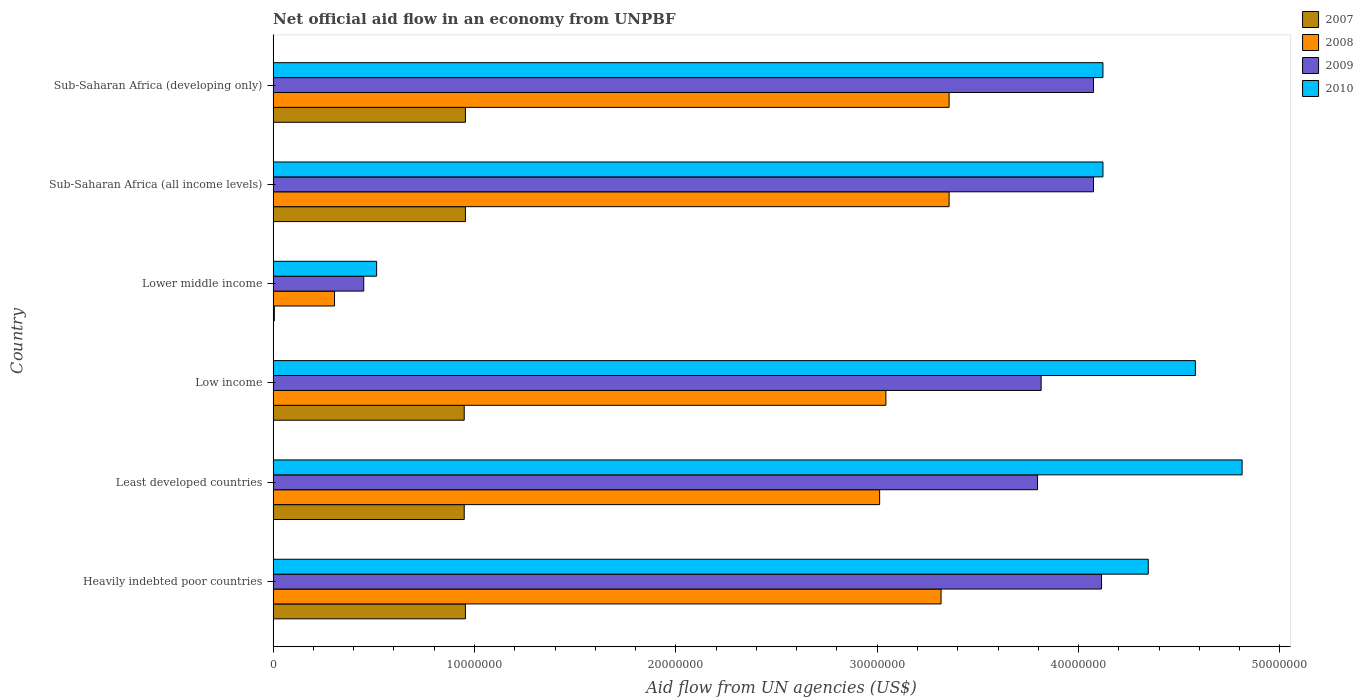How many groups of bars are there?
Offer a terse response. 6. How many bars are there on the 5th tick from the top?
Make the answer very short. 4. How many bars are there on the 4th tick from the bottom?
Your response must be concise. 4. What is the label of the 6th group of bars from the top?
Your response must be concise. Heavily indebted poor countries. In how many cases, is the number of bars for a given country not equal to the number of legend labels?
Provide a short and direct response. 0. What is the net official aid flow in 2009 in Sub-Saharan Africa (developing only)?
Keep it short and to the point. 4.07e+07. Across all countries, what is the maximum net official aid flow in 2010?
Your answer should be compact. 4.81e+07. Across all countries, what is the minimum net official aid flow in 2008?
Your response must be concise. 3.05e+06. In which country was the net official aid flow in 2010 maximum?
Ensure brevity in your answer.  Least developed countries. In which country was the net official aid flow in 2009 minimum?
Keep it short and to the point. Lower middle income. What is the total net official aid flow in 2008 in the graph?
Give a very brief answer. 1.64e+08. What is the difference between the net official aid flow in 2010 in Low income and that in Sub-Saharan Africa (all income levels)?
Offer a terse response. 4.59e+06. What is the difference between the net official aid flow in 2008 in Heavily indebted poor countries and the net official aid flow in 2009 in Low income?
Ensure brevity in your answer.  -4.97e+06. What is the average net official aid flow in 2008 per country?
Provide a succinct answer. 2.73e+07. What is the difference between the net official aid flow in 2008 and net official aid flow in 2009 in Low income?
Give a very brief answer. -7.71e+06. What is the ratio of the net official aid flow in 2010 in Low income to that in Sub-Saharan Africa (developing only)?
Your response must be concise. 1.11. Is the net official aid flow in 2010 in Heavily indebted poor countries less than that in Sub-Saharan Africa (developing only)?
Your answer should be compact. No. Is the difference between the net official aid flow in 2008 in Low income and Sub-Saharan Africa (developing only) greater than the difference between the net official aid flow in 2009 in Low income and Sub-Saharan Africa (developing only)?
Ensure brevity in your answer.  No. What is the difference between the highest and the lowest net official aid flow in 2009?
Your answer should be very brief. 3.66e+07. Is the sum of the net official aid flow in 2009 in Least developed countries and Low income greater than the maximum net official aid flow in 2008 across all countries?
Ensure brevity in your answer.  Yes. What does the 3rd bar from the top in Heavily indebted poor countries represents?
Offer a terse response. 2008. Are all the bars in the graph horizontal?
Your answer should be compact. Yes. How many countries are there in the graph?
Ensure brevity in your answer.  6. What is the difference between two consecutive major ticks on the X-axis?
Give a very brief answer. 1.00e+07. Does the graph contain grids?
Provide a succinct answer. No. What is the title of the graph?
Your answer should be very brief. Net official aid flow in an economy from UNPBF. Does "1964" appear as one of the legend labels in the graph?
Make the answer very short. No. What is the label or title of the X-axis?
Provide a short and direct response. Aid flow from UN agencies (US$). What is the Aid flow from UN agencies (US$) of 2007 in Heavily indebted poor countries?
Your response must be concise. 9.55e+06. What is the Aid flow from UN agencies (US$) of 2008 in Heavily indebted poor countries?
Make the answer very short. 3.32e+07. What is the Aid flow from UN agencies (US$) in 2009 in Heavily indebted poor countries?
Provide a succinct answer. 4.11e+07. What is the Aid flow from UN agencies (US$) of 2010 in Heavily indebted poor countries?
Your answer should be compact. 4.35e+07. What is the Aid flow from UN agencies (US$) in 2007 in Least developed countries?
Give a very brief answer. 9.49e+06. What is the Aid flow from UN agencies (US$) of 2008 in Least developed countries?
Offer a very short reply. 3.01e+07. What is the Aid flow from UN agencies (US$) in 2009 in Least developed countries?
Offer a very short reply. 3.80e+07. What is the Aid flow from UN agencies (US$) of 2010 in Least developed countries?
Keep it short and to the point. 4.81e+07. What is the Aid flow from UN agencies (US$) of 2007 in Low income?
Offer a terse response. 9.49e+06. What is the Aid flow from UN agencies (US$) of 2008 in Low income?
Keep it short and to the point. 3.04e+07. What is the Aid flow from UN agencies (US$) of 2009 in Low income?
Ensure brevity in your answer.  3.81e+07. What is the Aid flow from UN agencies (US$) of 2010 in Low income?
Your response must be concise. 4.58e+07. What is the Aid flow from UN agencies (US$) of 2007 in Lower middle income?
Your answer should be compact. 6.00e+04. What is the Aid flow from UN agencies (US$) of 2008 in Lower middle income?
Ensure brevity in your answer.  3.05e+06. What is the Aid flow from UN agencies (US$) of 2009 in Lower middle income?
Provide a short and direct response. 4.50e+06. What is the Aid flow from UN agencies (US$) in 2010 in Lower middle income?
Keep it short and to the point. 5.14e+06. What is the Aid flow from UN agencies (US$) of 2007 in Sub-Saharan Africa (all income levels)?
Ensure brevity in your answer.  9.55e+06. What is the Aid flow from UN agencies (US$) of 2008 in Sub-Saharan Africa (all income levels)?
Your response must be concise. 3.36e+07. What is the Aid flow from UN agencies (US$) of 2009 in Sub-Saharan Africa (all income levels)?
Your response must be concise. 4.07e+07. What is the Aid flow from UN agencies (US$) of 2010 in Sub-Saharan Africa (all income levels)?
Your response must be concise. 4.12e+07. What is the Aid flow from UN agencies (US$) in 2007 in Sub-Saharan Africa (developing only)?
Keep it short and to the point. 9.55e+06. What is the Aid flow from UN agencies (US$) of 2008 in Sub-Saharan Africa (developing only)?
Provide a short and direct response. 3.36e+07. What is the Aid flow from UN agencies (US$) of 2009 in Sub-Saharan Africa (developing only)?
Offer a terse response. 4.07e+07. What is the Aid flow from UN agencies (US$) in 2010 in Sub-Saharan Africa (developing only)?
Provide a short and direct response. 4.12e+07. Across all countries, what is the maximum Aid flow from UN agencies (US$) of 2007?
Offer a very short reply. 9.55e+06. Across all countries, what is the maximum Aid flow from UN agencies (US$) in 2008?
Your answer should be very brief. 3.36e+07. Across all countries, what is the maximum Aid flow from UN agencies (US$) of 2009?
Your answer should be compact. 4.11e+07. Across all countries, what is the maximum Aid flow from UN agencies (US$) in 2010?
Offer a terse response. 4.81e+07. Across all countries, what is the minimum Aid flow from UN agencies (US$) of 2007?
Offer a very short reply. 6.00e+04. Across all countries, what is the minimum Aid flow from UN agencies (US$) in 2008?
Provide a succinct answer. 3.05e+06. Across all countries, what is the minimum Aid flow from UN agencies (US$) of 2009?
Ensure brevity in your answer.  4.50e+06. Across all countries, what is the minimum Aid flow from UN agencies (US$) of 2010?
Ensure brevity in your answer.  5.14e+06. What is the total Aid flow from UN agencies (US$) in 2007 in the graph?
Ensure brevity in your answer.  4.77e+07. What is the total Aid flow from UN agencies (US$) in 2008 in the graph?
Provide a succinct answer. 1.64e+08. What is the total Aid flow from UN agencies (US$) of 2009 in the graph?
Provide a succinct answer. 2.03e+08. What is the total Aid flow from UN agencies (US$) of 2010 in the graph?
Your answer should be very brief. 2.25e+08. What is the difference between the Aid flow from UN agencies (US$) in 2007 in Heavily indebted poor countries and that in Least developed countries?
Ensure brevity in your answer.  6.00e+04. What is the difference between the Aid flow from UN agencies (US$) of 2008 in Heavily indebted poor countries and that in Least developed countries?
Make the answer very short. 3.05e+06. What is the difference between the Aid flow from UN agencies (US$) of 2009 in Heavily indebted poor countries and that in Least developed countries?
Give a very brief answer. 3.18e+06. What is the difference between the Aid flow from UN agencies (US$) in 2010 in Heavily indebted poor countries and that in Least developed countries?
Your answer should be very brief. -4.66e+06. What is the difference between the Aid flow from UN agencies (US$) in 2008 in Heavily indebted poor countries and that in Low income?
Make the answer very short. 2.74e+06. What is the difference between the Aid flow from UN agencies (US$) of 2009 in Heavily indebted poor countries and that in Low income?
Give a very brief answer. 3.00e+06. What is the difference between the Aid flow from UN agencies (US$) in 2010 in Heavily indebted poor countries and that in Low income?
Provide a succinct answer. -2.34e+06. What is the difference between the Aid flow from UN agencies (US$) in 2007 in Heavily indebted poor countries and that in Lower middle income?
Keep it short and to the point. 9.49e+06. What is the difference between the Aid flow from UN agencies (US$) in 2008 in Heavily indebted poor countries and that in Lower middle income?
Offer a very short reply. 3.01e+07. What is the difference between the Aid flow from UN agencies (US$) of 2009 in Heavily indebted poor countries and that in Lower middle income?
Your answer should be very brief. 3.66e+07. What is the difference between the Aid flow from UN agencies (US$) of 2010 in Heavily indebted poor countries and that in Lower middle income?
Offer a terse response. 3.83e+07. What is the difference between the Aid flow from UN agencies (US$) in 2007 in Heavily indebted poor countries and that in Sub-Saharan Africa (all income levels)?
Offer a terse response. 0. What is the difference between the Aid flow from UN agencies (US$) of 2008 in Heavily indebted poor countries and that in Sub-Saharan Africa (all income levels)?
Provide a short and direct response. -4.00e+05. What is the difference between the Aid flow from UN agencies (US$) of 2009 in Heavily indebted poor countries and that in Sub-Saharan Africa (all income levels)?
Your answer should be compact. 4.00e+05. What is the difference between the Aid flow from UN agencies (US$) of 2010 in Heavily indebted poor countries and that in Sub-Saharan Africa (all income levels)?
Make the answer very short. 2.25e+06. What is the difference between the Aid flow from UN agencies (US$) of 2008 in Heavily indebted poor countries and that in Sub-Saharan Africa (developing only)?
Provide a succinct answer. -4.00e+05. What is the difference between the Aid flow from UN agencies (US$) in 2010 in Heavily indebted poor countries and that in Sub-Saharan Africa (developing only)?
Give a very brief answer. 2.25e+06. What is the difference between the Aid flow from UN agencies (US$) in 2008 in Least developed countries and that in Low income?
Offer a terse response. -3.10e+05. What is the difference between the Aid flow from UN agencies (US$) of 2009 in Least developed countries and that in Low income?
Offer a very short reply. -1.80e+05. What is the difference between the Aid flow from UN agencies (US$) of 2010 in Least developed countries and that in Low income?
Provide a succinct answer. 2.32e+06. What is the difference between the Aid flow from UN agencies (US$) in 2007 in Least developed countries and that in Lower middle income?
Offer a very short reply. 9.43e+06. What is the difference between the Aid flow from UN agencies (US$) of 2008 in Least developed countries and that in Lower middle income?
Give a very brief answer. 2.71e+07. What is the difference between the Aid flow from UN agencies (US$) of 2009 in Least developed countries and that in Lower middle income?
Offer a very short reply. 3.35e+07. What is the difference between the Aid flow from UN agencies (US$) of 2010 in Least developed countries and that in Lower middle income?
Provide a succinct answer. 4.30e+07. What is the difference between the Aid flow from UN agencies (US$) of 2008 in Least developed countries and that in Sub-Saharan Africa (all income levels)?
Your answer should be very brief. -3.45e+06. What is the difference between the Aid flow from UN agencies (US$) of 2009 in Least developed countries and that in Sub-Saharan Africa (all income levels)?
Keep it short and to the point. -2.78e+06. What is the difference between the Aid flow from UN agencies (US$) in 2010 in Least developed countries and that in Sub-Saharan Africa (all income levels)?
Keep it short and to the point. 6.91e+06. What is the difference between the Aid flow from UN agencies (US$) of 2008 in Least developed countries and that in Sub-Saharan Africa (developing only)?
Ensure brevity in your answer.  -3.45e+06. What is the difference between the Aid flow from UN agencies (US$) of 2009 in Least developed countries and that in Sub-Saharan Africa (developing only)?
Make the answer very short. -2.78e+06. What is the difference between the Aid flow from UN agencies (US$) in 2010 in Least developed countries and that in Sub-Saharan Africa (developing only)?
Offer a terse response. 6.91e+06. What is the difference between the Aid flow from UN agencies (US$) in 2007 in Low income and that in Lower middle income?
Keep it short and to the point. 9.43e+06. What is the difference between the Aid flow from UN agencies (US$) of 2008 in Low income and that in Lower middle income?
Your response must be concise. 2.74e+07. What is the difference between the Aid flow from UN agencies (US$) of 2009 in Low income and that in Lower middle income?
Provide a short and direct response. 3.36e+07. What is the difference between the Aid flow from UN agencies (US$) in 2010 in Low income and that in Lower middle income?
Your response must be concise. 4.07e+07. What is the difference between the Aid flow from UN agencies (US$) in 2008 in Low income and that in Sub-Saharan Africa (all income levels)?
Keep it short and to the point. -3.14e+06. What is the difference between the Aid flow from UN agencies (US$) of 2009 in Low income and that in Sub-Saharan Africa (all income levels)?
Your answer should be very brief. -2.60e+06. What is the difference between the Aid flow from UN agencies (US$) of 2010 in Low income and that in Sub-Saharan Africa (all income levels)?
Your answer should be compact. 4.59e+06. What is the difference between the Aid flow from UN agencies (US$) in 2007 in Low income and that in Sub-Saharan Africa (developing only)?
Your answer should be very brief. -6.00e+04. What is the difference between the Aid flow from UN agencies (US$) in 2008 in Low income and that in Sub-Saharan Africa (developing only)?
Your answer should be very brief. -3.14e+06. What is the difference between the Aid flow from UN agencies (US$) of 2009 in Low income and that in Sub-Saharan Africa (developing only)?
Provide a short and direct response. -2.60e+06. What is the difference between the Aid flow from UN agencies (US$) of 2010 in Low income and that in Sub-Saharan Africa (developing only)?
Ensure brevity in your answer.  4.59e+06. What is the difference between the Aid flow from UN agencies (US$) in 2007 in Lower middle income and that in Sub-Saharan Africa (all income levels)?
Give a very brief answer. -9.49e+06. What is the difference between the Aid flow from UN agencies (US$) of 2008 in Lower middle income and that in Sub-Saharan Africa (all income levels)?
Your answer should be very brief. -3.05e+07. What is the difference between the Aid flow from UN agencies (US$) of 2009 in Lower middle income and that in Sub-Saharan Africa (all income levels)?
Keep it short and to the point. -3.62e+07. What is the difference between the Aid flow from UN agencies (US$) of 2010 in Lower middle income and that in Sub-Saharan Africa (all income levels)?
Offer a very short reply. -3.61e+07. What is the difference between the Aid flow from UN agencies (US$) of 2007 in Lower middle income and that in Sub-Saharan Africa (developing only)?
Keep it short and to the point. -9.49e+06. What is the difference between the Aid flow from UN agencies (US$) of 2008 in Lower middle income and that in Sub-Saharan Africa (developing only)?
Make the answer very short. -3.05e+07. What is the difference between the Aid flow from UN agencies (US$) of 2009 in Lower middle income and that in Sub-Saharan Africa (developing only)?
Your answer should be compact. -3.62e+07. What is the difference between the Aid flow from UN agencies (US$) of 2010 in Lower middle income and that in Sub-Saharan Africa (developing only)?
Your answer should be compact. -3.61e+07. What is the difference between the Aid flow from UN agencies (US$) in 2007 in Sub-Saharan Africa (all income levels) and that in Sub-Saharan Africa (developing only)?
Offer a terse response. 0. What is the difference between the Aid flow from UN agencies (US$) in 2009 in Sub-Saharan Africa (all income levels) and that in Sub-Saharan Africa (developing only)?
Give a very brief answer. 0. What is the difference between the Aid flow from UN agencies (US$) of 2007 in Heavily indebted poor countries and the Aid flow from UN agencies (US$) of 2008 in Least developed countries?
Provide a short and direct response. -2.06e+07. What is the difference between the Aid flow from UN agencies (US$) in 2007 in Heavily indebted poor countries and the Aid flow from UN agencies (US$) in 2009 in Least developed countries?
Give a very brief answer. -2.84e+07. What is the difference between the Aid flow from UN agencies (US$) in 2007 in Heavily indebted poor countries and the Aid flow from UN agencies (US$) in 2010 in Least developed countries?
Your answer should be compact. -3.86e+07. What is the difference between the Aid flow from UN agencies (US$) in 2008 in Heavily indebted poor countries and the Aid flow from UN agencies (US$) in 2009 in Least developed countries?
Offer a very short reply. -4.79e+06. What is the difference between the Aid flow from UN agencies (US$) of 2008 in Heavily indebted poor countries and the Aid flow from UN agencies (US$) of 2010 in Least developed countries?
Make the answer very short. -1.50e+07. What is the difference between the Aid flow from UN agencies (US$) of 2009 in Heavily indebted poor countries and the Aid flow from UN agencies (US$) of 2010 in Least developed countries?
Provide a succinct answer. -6.98e+06. What is the difference between the Aid flow from UN agencies (US$) of 2007 in Heavily indebted poor countries and the Aid flow from UN agencies (US$) of 2008 in Low income?
Ensure brevity in your answer.  -2.09e+07. What is the difference between the Aid flow from UN agencies (US$) of 2007 in Heavily indebted poor countries and the Aid flow from UN agencies (US$) of 2009 in Low income?
Offer a terse response. -2.86e+07. What is the difference between the Aid flow from UN agencies (US$) in 2007 in Heavily indebted poor countries and the Aid flow from UN agencies (US$) in 2010 in Low income?
Your response must be concise. -3.62e+07. What is the difference between the Aid flow from UN agencies (US$) in 2008 in Heavily indebted poor countries and the Aid flow from UN agencies (US$) in 2009 in Low income?
Make the answer very short. -4.97e+06. What is the difference between the Aid flow from UN agencies (US$) of 2008 in Heavily indebted poor countries and the Aid flow from UN agencies (US$) of 2010 in Low income?
Your answer should be very brief. -1.26e+07. What is the difference between the Aid flow from UN agencies (US$) in 2009 in Heavily indebted poor countries and the Aid flow from UN agencies (US$) in 2010 in Low income?
Your response must be concise. -4.66e+06. What is the difference between the Aid flow from UN agencies (US$) of 2007 in Heavily indebted poor countries and the Aid flow from UN agencies (US$) of 2008 in Lower middle income?
Offer a very short reply. 6.50e+06. What is the difference between the Aid flow from UN agencies (US$) of 2007 in Heavily indebted poor countries and the Aid flow from UN agencies (US$) of 2009 in Lower middle income?
Keep it short and to the point. 5.05e+06. What is the difference between the Aid flow from UN agencies (US$) of 2007 in Heavily indebted poor countries and the Aid flow from UN agencies (US$) of 2010 in Lower middle income?
Offer a terse response. 4.41e+06. What is the difference between the Aid flow from UN agencies (US$) of 2008 in Heavily indebted poor countries and the Aid flow from UN agencies (US$) of 2009 in Lower middle income?
Make the answer very short. 2.87e+07. What is the difference between the Aid flow from UN agencies (US$) in 2008 in Heavily indebted poor countries and the Aid flow from UN agencies (US$) in 2010 in Lower middle income?
Provide a short and direct response. 2.80e+07. What is the difference between the Aid flow from UN agencies (US$) in 2009 in Heavily indebted poor countries and the Aid flow from UN agencies (US$) in 2010 in Lower middle income?
Make the answer very short. 3.60e+07. What is the difference between the Aid flow from UN agencies (US$) of 2007 in Heavily indebted poor countries and the Aid flow from UN agencies (US$) of 2008 in Sub-Saharan Africa (all income levels)?
Offer a very short reply. -2.40e+07. What is the difference between the Aid flow from UN agencies (US$) of 2007 in Heavily indebted poor countries and the Aid flow from UN agencies (US$) of 2009 in Sub-Saharan Africa (all income levels)?
Your answer should be very brief. -3.12e+07. What is the difference between the Aid flow from UN agencies (US$) of 2007 in Heavily indebted poor countries and the Aid flow from UN agencies (US$) of 2010 in Sub-Saharan Africa (all income levels)?
Your response must be concise. -3.17e+07. What is the difference between the Aid flow from UN agencies (US$) of 2008 in Heavily indebted poor countries and the Aid flow from UN agencies (US$) of 2009 in Sub-Saharan Africa (all income levels)?
Your answer should be very brief. -7.57e+06. What is the difference between the Aid flow from UN agencies (US$) of 2008 in Heavily indebted poor countries and the Aid flow from UN agencies (US$) of 2010 in Sub-Saharan Africa (all income levels)?
Keep it short and to the point. -8.04e+06. What is the difference between the Aid flow from UN agencies (US$) in 2009 in Heavily indebted poor countries and the Aid flow from UN agencies (US$) in 2010 in Sub-Saharan Africa (all income levels)?
Offer a very short reply. -7.00e+04. What is the difference between the Aid flow from UN agencies (US$) of 2007 in Heavily indebted poor countries and the Aid flow from UN agencies (US$) of 2008 in Sub-Saharan Africa (developing only)?
Provide a succinct answer. -2.40e+07. What is the difference between the Aid flow from UN agencies (US$) in 2007 in Heavily indebted poor countries and the Aid flow from UN agencies (US$) in 2009 in Sub-Saharan Africa (developing only)?
Make the answer very short. -3.12e+07. What is the difference between the Aid flow from UN agencies (US$) in 2007 in Heavily indebted poor countries and the Aid flow from UN agencies (US$) in 2010 in Sub-Saharan Africa (developing only)?
Provide a short and direct response. -3.17e+07. What is the difference between the Aid flow from UN agencies (US$) of 2008 in Heavily indebted poor countries and the Aid flow from UN agencies (US$) of 2009 in Sub-Saharan Africa (developing only)?
Offer a very short reply. -7.57e+06. What is the difference between the Aid flow from UN agencies (US$) of 2008 in Heavily indebted poor countries and the Aid flow from UN agencies (US$) of 2010 in Sub-Saharan Africa (developing only)?
Keep it short and to the point. -8.04e+06. What is the difference between the Aid flow from UN agencies (US$) in 2009 in Heavily indebted poor countries and the Aid flow from UN agencies (US$) in 2010 in Sub-Saharan Africa (developing only)?
Your response must be concise. -7.00e+04. What is the difference between the Aid flow from UN agencies (US$) of 2007 in Least developed countries and the Aid flow from UN agencies (US$) of 2008 in Low income?
Ensure brevity in your answer.  -2.09e+07. What is the difference between the Aid flow from UN agencies (US$) in 2007 in Least developed countries and the Aid flow from UN agencies (US$) in 2009 in Low income?
Ensure brevity in your answer.  -2.86e+07. What is the difference between the Aid flow from UN agencies (US$) of 2007 in Least developed countries and the Aid flow from UN agencies (US$) of 2010 in Low income?
Provide a succinct answer. -3.63e+07. What is the difference between the Aid flow from UN agencies (US$) in 2008 in Least developed countries and the Aid flow from UN agencies (US$) in 2009 in Low income?
Your answer should be very brief. -8.02e+06. What is the difference between the Aid flow from UN agencies (US$) of 2008 in Least developed countries and the Aid flow from UN agencies (US$) of 2010 in Low income?
Give a very brief answer. -1.57e+07. What is the difference between the Aid flow from UN agencies (US$) in 2009 in Least developed countries and the Aid flow from UN agencies (US$) in 2010 in Low income?
Your answer should be very brief. -7.84e+06. What is the difference between the Aid flow from UN agencies (US$) of 2007 in Least developed countries and the Aid flow from UN agencies (US$) of 2008 in Lower middle income?
Provide a succinct answer. 6.44e+06. What is the difference between the Aid flow from UN agencies (US$) of 2007 in Least developed countries and the Aid flow from UN agencies (US$) of 2009 in Lower middle income?
Provide a short and direct response. 4.99e+06. What is the difference between the Aid flow from UN agencies (US$) in 2007 in Least developed countries and the Aid flow from UN agencies (US$) in 2010 in Lower middle income?
Your answer should be compact. 4.35e+06. What is the difference between the Aid flow from UN agencies (US$) in 2008 in Least developed countries and the Aid flow from UN agencies (US$) in 2009 in Lower middle income?
Give a very brief answer. 2.56e+07. What is the difference between the Aid flow from UN agencies (US$) in 2008 in Least developed countries and the Aid flow from UN agencies (US$) in 2010 in Lower middle income?
Your answer should be compact. 2.50e+07. What is the difference between the Aid flow from UN agencies (US$) of 2009 in Least developed countries and the Aid flow from UN agencies (US$) of 2010 in Lower middle income?
Keep it short and to the point. 3.28e+07. What is the difference between the Aid flow from UN agencies (US$) in 2007 in Least developed countries and the Aid flow from UN agencies (US$) in 2008 in Sub-Saharan Africa (all income levels)?
Keep it short and to the point. -2.41e+07. What is the difference between the Aid flow from UN agencies (US$) in 2007 in Least developed countries and the Aid flow from UN agencies (US$) in 2009 in Sub-Saharan Africa (all income levels)?
Ensure brevity in your answer.  -3.12e+07. What is the difference between the Aid flow from UN agencies (US$) in 2007 in Least developed countries and the Aid flow from UN agencies (US$) in 2010 in Sub-Saharan Africa (all income levels)?
Offer a terse response. -3.17e+07. What is the difference between the Aid flow from UN agencies (US$) of 2008 in Least developed countries and the Aid flow from UN agencies (US$) of 2009 in Sub-Saharan Africa (all income levels)?
Your answer should be very brief. -1.06e+07. What is the difference between the Aid flow from UN agencies (US$) in 2008 in Least developed countries and the Aid flow from UN agencies (US$) in 2010 in Sub-Saharan Africa (all income levels)?
Ensure brevity in your answer.  -1.11e+07. What is the difference between the Aid flow from UN agencies (US$) in 2009 in Least developed countries and the Aid flow from UN agencies (US$) in 2010 in Sub-Saharan Africa (all income levels)?
Your response must be concise. -3.25e+06. What is the difference between the Aid flow from UN agencies (US$) in 2007 in Least developed countries and the Aid flow from UN agencies (US$) in 2008 in Sub-Saharan Africa (developing only)?
Make the answer very short. -2.41e+07. What is the difference between the Aid flow from UN agencies (US$) in 2007 in Least developed countries and the Aid flow from UN agencies (US$) in 2009 in Sub-Saharan Africa (developing only)?
Ensure brevity in your answer.  -3.12e+07. What is the difference between the Aid flow from UN agencies (US$) of 2007 in Least developed countries and the Aid flow from UN agencies (US$) of 2010 in Sub-Saharan Africa (developing only)?
Give a very brief answer. -3.17e+07. What is the difference between the Aid flow from UN agencies (US$) of 2008 in Least developed countries and the Aid flow from UN agencies (US$) of 2009 in Sub-Saharan Africa (developing only)?
Provide a short and direct response. -1.06e+07. What is the difference between the Aid flow from UN agencies (US$) in 2008 in Least developed countries and the Aid flow from UN agencies (US$) in 2010 in Sub-Saharan Africa (developing only)?
Offer a very short reply. -1.11e+07. What is the difference between the Aid flow from UN agencies (US$) in 2009 in Least developed countries and the Aid flow from UN agencies (US$) in 2010 in Sub-Saharan Africa (developing only)?
Provide a short and direct response. -3.25e+06. What is the difference between the Aid flow from UN agencies (US$) in 2007 in Low income and the Aid flow from UN agencies (US$) in 2008 in Lower middle income?
Make the answer very short. 6.44e+06. What is the difference between the Aid flow from UN agencies (US$) in 2007 in Low income and the Aid flow from UN agencies (US$) in 2009 in Lower middle income?
Ensure brevity in your answer.  4.99e+06. What is the difference between the Aid flow from UN agencies (US$) of 2007 in Low income and the Aid flow from UN agencies (US$) of 2010 in Lower middle income?
Keep it short and to the point. 4.35e+06. What is the difference between the Aid flow from UN agencies (US$) of 2008 in Low income and the Aid flow from UN agencies (US$) of 2009 in Lower middle income?
Offer a very short reply. 2.59e+07. What is the difference between the Aid flow from UN agencies (US$) in 2008 in Low income and the Aid flow from UN agencies (US$) in 2010 in Lower middle income?
Your answer should be compact. 2.53e+07. What is the difference between the Aid flow from UN agencies (US$) in 2009 in Low income and the Aid flow from UN agencies (US$) in 2010 in Lower middle income?
Keep it short and to the point. 3.30e+07. What is the difference between the Aid flow from UN agencies (US$) in 2007 in Low income and the Aid flow from UN agencies (US$) in 2008 in Sub-Saharan Africa (all income levels)?
Keep it short and to the point. -2.41e+07. What is the difference between the Aid flow from UN agencies (US$) in 2007 in Low income and the Aid flow from UN agencies (US$) in 2009 in Sub-Saharan Africa (all income levels)?
Give a very brief answer. -3.12e+07. What is the difference between the Aid flow from UN agencies (US$) in 2007 in Low income and the Aid flow from UN agencies (US$) in 2010 in Sub-Saharan Africa (all income levels)?
Ensure brevity in your answer.  -3.17e+07. What is the difference between the Aid flow from UN agencies (US$) in 2008 in Low income and the Aid flow from UN agencies (US$) in 2009 in Sub-Saharan Africa (all income levels)?
Offer a very short reply. -1.03e+07. What is the difference between the Aid flow from UN agencies (US$) of 2008 in Low income and the Aid flow from UN agencies (US$) of 2010 in Sub-Saharan Africa (all income levels)?
Offer a very short reply. -1.08e+07. What is the difference between the Aid flow from UN agencies (US$) of 2009 in Low income and the Aid flow from UN agencies (US$) of 2010 in Sub-Saharan Africa (all income levels)?
Give a very brief answer. -3.07e+06. What is the difference between the Aid flow from UN agencies (US$) of 2007 in Low income and the Aid flow from UN agencies (US$) of 2008 in Sub-Saharan Africa (developing only)?
Keep it short and to the point. -2.41e+07. What is the difference between the Aid flow from UN agencies (US$) of 2007 in Low income and the Aid flow from UN agencies (US$) of 2009 in Sub-Saharan Africa (developing only)?
Your answer should be compact. -3.12e+07. What is the difference between the Aid flow from UN agencies (US$) of 2007 in Low income and the Aid flow from UN agencies (US$) of 2010 in Sub-Saharan Africa (developing only)?
Provide a succinct answer. -3.17e+07. What is the difference between the Aid flow from UN agencies (US$) of 2008 in Low income and the Aid flow from UN agencies (US$) of 2009 in Sub-Saharan Africa (developing only)?
Keep it short and to the point. -1.03e+07. What is the difference between the Aid flow from UN agencies (US$) of 2008 in Low income and the Aid flow from UN agencies (US$) of 2010 in Sub-Saharan Africa (developing only)?
Make the answer very short. -1.08e+07. What is the difference between the Aid flow from UN agencies (US$) of 2009 in Low income and the Aid flow from UN agencies (US$) of 2010 in Sub-Saharan Africa (developing only)?
Give a very brief answer. -3.07e+06. What is the difference between the Aid flow from UN agencies (US$) of 2007 in Lower middle income and the Aid flow from UN agencies (US$) of 2008 in Sub-Saharan Africa (all income levels)?
Provide a succinct answer. -3.35e+07. What is the difference between the Aid flow from UN agencies (US$) in 2007 in Lower middle income and the Aid flow from UN agencies (US$) in 2009 in Sub-Saharan Africa (all income levels)?
Offer a very short reply. -4.07e+07. What is the difference between the Aid flow from UN agencies (US$) of 2007 in Lower middle income and the Aid flow from UN agencies (US$) of 2010 in Sub-Saharan Africa (all income levels)?
Give a very brief answer. -4.12e+07. What is the difference between the Aid flow from UN agencies (US$) of 2008 in Lower middle income and the Aid flow from UN agencies (US$) of 2009 in Sub-Saharan Africa (all income levels)?
Give a very brief answer. -3.77e+07. What is the difference between the Aid flow from UN agencies (US$) in 2008 in Lower middle income and the Aid flow from UN agencies (US$) in 2010 in Sub-Saharan Africa (all income levels)?
Keep it short and to the point. -3.82e+07. What is the difference between the Aid flow from UN agencies (US$) of 2009 in Lower middle income and the Aid flow from UN agencies (US$) of 2010 in Sub-Saharan Africa (all income levels)?
Make the answer very short. -3.67e+07. What is the difference between the Aid flow from UN agencies (US$) of 2007 in Lower middle income and the Aid flow from UN agencies (US$) of 2008 in Sub-Saharan Africa (developing only)?
Provide a short and direct response. -3.35e+07. What is the difference between the Aid flow from UN agencies (US$) in 2007 in Lower middle income and the Aid flow from UN agencies (US$) in 2009 in Sub-Saharan Africa (developing only)?
Make the answer very short. -4.07e+07. What is the difference between the Aid flow from UN agencies (US$) of 2007 in Lower middle income and the Aid flow from UN agencies (US$) of 2010 in Sub-Saharan Africa (developing only)?
Your answer should be compact. -4.12e+07. What is the difference between the Aid flow from UN agencies (US$) of 2008 in Lower middle income and the Aid flow from UN agencies (US$) of 2009 in Sub-Saharan Africa (developing only)?
Your answer should be very brief. -3.77e+07. What is the difference between the Aid flow from UN agencies (US$) in 2008 in Lower middle income and the Aid flow from UN agencies (US$) in 2010 in Sub-Saharan Africa (developing only)?
Offer a terse response. -3.82e+07. What is the difference between the Aid flow from UN agencies (US$) of 2009 in Lower middle income and the Aid flow from UN agencies (US$) of 2010 in Sub-Saharan Africa (developing only)?
Offer a terse response. -3.67e+07. What is the difference between the Aid flow from UN agencies (US$) of 2007 in Sub-Saharan Africa (all income levels) and the Aid flow from UN agencies (US$) of 2008 in Sub-Saharan Africa (developing only)?
Offer a very short reply. -2.40e+07. What is the difference between the Aid flow from UN agencies (US$) of 2007 in Sub-Saharan Africa (all income levels) and the Aid flow from UN agencies (US$) of 2009 in Sub-Saharan Africa (developing only)?
Provide a succinct answer. -3.12e+07. What is the difference between the Aid flow from UN agencies (US$) of 2007 in Sub-Saharan Africa (all income levels) and the Aid flow from UN agencies (US$) of 2010 in Sub-Saharan Africa (developing only)?
Your answer should be compact. -3.17e+07. What is the difference between the Aid flow from UN agencies (US$) in 2008 in Sub-Saharan Africa (all income levels) and the Aid flow from UN agencies (US$) in 2009 in Sub-Saharan Africa (developing only)?
Offer a terse response. -7.17e+06. What is the difference between the Aid flow from UN agencies (US$) in 2008 in Sub-Saharan Africa (all income levels) and the Aid flow from UN agencies (US$) in 2010 in Sub-Saharan Africa (developing only)?
Provide a short and direct response. -7.64e+06. What is the difference between the Aid flow from UN agencies (US$) of 2009 in Sub-Saharan Africa (all income levels) and the Aid flow from UN agencies (US$) of 2010 in Sub-Saharan Africa (developing only)?
Give a very brief answer. -4.70e+05. What is the average Aid flow from UN agencies (US$) in 2007 per country?
Your answer should be very brief. 7.95e+06. What is the average Aid flow from UN agencies (US$) of 2008 per country?
Give a very brief answer. 2.73e+07. What is the average Aid flow from UN agencies (US$) in 2009 per country?
Offer a terse response. 3.39e+07. What is the average Aid flow from UN agencies (US$) in 2010 per country?
Provide a succinct answer. 3.75e+07. What is the difference between the Aid flow from UN agencies (US$) of 2007 and Aid flow from UN agencies (US$) of 2008 in Heavily indebted poor countries?
Your answer should be compact. -2.36e+07. What is the difference between the Aid flow from UN agencies (US$) of 2007 and Aid flow from UN agencies (US$) of 2009 in Heavily indebted poor countries?
Your response must be concise. -3.16e+07. What is the difference between the Aid flow from UN agencies (US$) in 2007 and Aid flow from UN agencies (US$) in 2010 in Heavily indebted poor countries?
Ensure brevity in your answer.  -3.39e+07. What is the difference between the Aid flow from UN agencies (US$) of 2008 and Aid flow from UN agencies (US$) of 2009 in Heavily indebted poor countries?
Ensure brevity in your answer.  -7.97e+06. What is the difference between the Aid flow from UN agencies (US$) of 2008 and Aid flow from UN agencies (US$) of 2010 in Heavily indebted poor countries?
Keep it short and to the point. -1.03e+07. What is the difference between the Aid flow from UN agencies (US$) in 2009 and Aid flow from UN agencies (US$) in 2010 in Heavily indebted poor countries?
Give a very brief answer. -2.32e+06. What is the difference between the Aid flow from UN agencies (US$) in 2007 and Aid flow from UN agencies (US$) in 2008 in Least developed countries?
Offer a terse response. -2.06e+07. What is the difference between the Aid flow from UN agencies (US$) in 2007 and Aid flow from UN agencies (US$) in 2009 in Least developed countries?
Make the answer very short. -2.85e+07. What is the difference between the Aid flow from UN agencies (US$) of 2007 and Aid flow from UN agencies (US$) of 2010 in Least developed countries?
Make the answer very short. -3.86e+07. What is the difference between the Aid flow from UN agencies (US$) in 2008 and Aid flow from UN agencies (US$) in 2009 in Least developed countries?
Make the answer very short. -7.84e+06. What is the difference between the Aid flow from UN agencies (US$) in 2008 and Aid flow from UN agencies (US$) in 2010 in Least developed countries?
Your answer should be compact. -1.80e+07. What is the difference between the Aid flow from UN agencies (US$) in 2009 and Aid flow from UN agencies (US$) in 2010 in Least developed countries?
Offer a terse response. -1.02e+07. What is the difference between the Aid flow from UN agencies (US$) in 2007 and Aid flow from UN agencies (US$) in 2008 in Low income?
Keep it short and to the point. -2.09e+07. What is the difference between the Aid flow from UN agencies (US$) of 2007 and Aid flow from UN agencies (US$) of 2009 in Low income?
Provide a succinct answer. -2.86e+07. What is the difference between the Aid flow from UN agencies (US$) of 2007 and Aid flow from UN agencies (US$) of 2010 in Low income?
Offer a terse response. -3.63e+07. What is the difference between the Aid flow from UN agencies (US$) of 2008 and Aid flow from UN agencies (US$) of 2009 in Low income?
Provide a succinct answer. -7.71e+06. What is the difference between the Aid flow from UN agencies (US$) in 2008 and Aid flow from UN agencies (US$) in 2010 in Low income?
Keep it short and to the point. -1.54e+07. What is the difference between the Aid flow from UN agencies (US$) of 2009 and Aid flow from UN agencies (US$) of 2010 in Low income?
Offer a terse response. -7.66e+06. What is the difference between the Aid flow from UN agencies (US$) in 2007 and Aid flow from UN agencies (US$) in 2008 in Lower middle income?
Ensure brevity in your answer.  -2.99e+06. What is the difference between the Aid flow from UN agencies (US$) of 2007 and Aid flow from UN agencies (US$) of 2009 in Lower middle income?
Your answer should be compact. -4.44e+06. What is the difference between the Aid flow from UN agencies (US$) of 2007 and Aid flow from UN agencies (US$) of 2010 in Lower middle income?
Offer a terse response. -5.08e+06. What is the difference between the Aid flow from UN agencies (US$) of 2008 and Aid flow from UN agencies (US$) of 2009 in Lower middle income?
Make the answer very short. -1.45e+06. What is the difference between the Aid flow from UN agencies (US$) in 2008 and Aid flow from UN agencies (US$) in 2010 in Lower middle income?
Make the answer very short. -2.09e+06. What is the difference between the Aid flow from UN agencies (US$) of 2009 and Aid flow from UN agencies (US$) of 2010 in Lower middle income?
Keep it short and to the point. -6.40e+05. What is the difference between the Aid flow from UN agencies (US$) of 2007 and Aid flow from UN agencies (US$) of 2008 in Sub-Saharan Africa (all income levels)?
Your response must be concise. -2.40e+07. What is the difference between the Aid flow from UN agencies (US$) in 2007 and Aid flow from UN agencies (US$) in 2009 in Sub-Saharan Africa (all income levels)?
Make the answer very short. -3.12e+07. What is the difference between the Aid flow from UN agencies (US$) in 2007 and Aid flow from UN agencies (US$) in 2010 in Sub-Saharan Africa (all income levels)?
Ensure brevity in your answer.  -3.17e+07. What is the difference between the Aid flow from UN agencies (US$) in 2008 and Aid flow from UN agencies (US$) in 2009 in Sub-Saharan Africa (all income levels)?
Ensure brevity in your answer.  -7.17e+06. What is the difference between the Aid flow from UN agencies (US$) in 2008 and Aid flow from UN agencies (US$) in 2010 in Sub-Saharan Africa (all income levels)?
Offer a very short reply. -7.64e+06. What is the difference between the Aid flow from UN agencies (US$) of 2009 and Aid flow from UN agencies (US$) of 2010 in Sub-Saharan Africa (all income levels)?
Ensure brevity in your answer.  -4.70e+05. What is the difference between the Aid flow from UN agencies (US$) in 2007 and Aid flow from UN agencies (US$) in 2008 in Sub-Saharan Africa (developing only)?
Give a very brief answer. -2.40e+07. What is the difference between the Aid flow from UN agencies (US$) of 2007 and Aid flow from UN agencies (US$) of 2009 in Sub-Saharan Africa (developing only)?
Provide a short and direct response. -3.12e+07. What is the difference between the Aid flow from UN agencies (US$) in 2007 and Aid flow from UN agencies (US$) in 2010 in Sub-Saharan Africa (developing only)?
Your response must be concise. -3.17e+07. What is the difference between the Aid flow from UN agencies (US$) of 2008 and Aid flow from UN agencies (US$) of 2009 in Sub-Saharan Africa (developing only)?
Your answer should be compact. -7.17e+06. What is the difference between the Aid flow from UN agencies (US$) in 2008 and Aid flow from UN agencies (US$) in 2010 in Sub-Saharan Africa (developing only)?
Offer a very short reply. -7.64e+06. What is the difference between the Aid flow from UN agencies (US$) in 2009 and Aid flow from UN agencies (US$) in 2010 in Sub-Saharan Africa (developing only)?
Offer a very short reply. -4.70e+05. What is the ratio of the Aid flow from UN agencies (US$) of 2007 in Heavily indebted poor countries to that in Least developed countries?
Give a very brief answer. 1.01. What is the ratio of the Aid flow from UN agencies (US$) of 2008 in Heavily indebted poor countries to that in Least developed countries?
Offer a terse response. 1.1. What is the ratio of the Aid flow from UN agencies (US$) of 2009 in Heavily indebted poor countries to that in Least developed countries?
Offer a terse response. 1.08. What is the ratio of the Aid flow from UN agencies (US$) in 2010 in Heavily indebted poor countries to that in Least developed countries?
Give a very brief answer. 0.9. What is the ratio of the Aid flow from UN agencies (US$) in 2008 in Heavily indebted poor countries to that in Low income?
Ensure brevity in your answer.  1.09. What is the ratio of the Aid flow from UN agencies (US$) in 2009 in Heavily indebted poor countries to that in Low income?
Your answer should be compact. 1.08. What is the ratio of the Aid flow from UN agencies (US$) in 2010 in Heavily indebted poor countries to that in Low income?
Your response must be concise. 0.95. What is the ratio of the Aid flow from UN agencies (US$) of 2007 in Heavily indebted poor countries to that in Lower middle income?
Provide a succinct answer. 159.17. What is the ratio of the Aid flow from UN agencies (US$) in 2008 in Heavily indebted poor countries to that in Lower middle income?
Offer a very short reply. 10.88. What is the ratio of the Aid flow from UN agencies (US$) in 2009 in Heavily indebted poor countries to that in Lower middle income?
Keep it short and to the point. 9.14. What is the ratio of the Aid flow from UN agencies (US$) of 2010 in Heavily indebted poor countries to that in Lower middle income?
Give a very brief answer. 8.46. What is the ratio of the Aid flow from UN agencies (US$) in 2007 in Heavily indebted poor countries to that in Sub-Saharan Africa (all income levels)?
Ensure brevity in your answer.  1. What is the ratio of the Aid flow from UN agencies (US$) in 2009 in Heavily indebted poor countries to that in Sub-Saharan Africa (all income levels)?
Give a very brief answer. 1.01. What is the ratio of the Aid flow from UN agencies (US$) of 2010 in Heavily indebted poor countries to that in Sub-Saharan Africa (all income levels)?
Provide a succinct answer. 1.05. What is the ratio of the Aid flow from UN agencies (US$) of 2007 in Heavily indebted poor countries to that in Sub-Saharan Africa (developing only)?
Provide a short and direct response. 1. What is the ratio of the Aid flow from UN agencies (US$) of 2009 in Heavily indebted poor countries to that in Sub-Saharan Africa (developing only)?
Give a very brief answer. 1.01. What is the ratio of the Aid flow from UN agencies (US$) of 2010 in Heavily indebted poor countries to that in Sub-Saharan Africa (developing only)?
Provide a short and direct response. 1.05. What is the ratio of the Aid flow from UN agencies (US$) of 2008 in Least developed countries to that in Low income?
Keep it short and to the point. 0.99. What is the ratio of the Aid flow from UN agencies (US$) of 2010 in Least developed countries to that in Low income?
Ensure brevity in your answer.  1.05. What is the ratio of the Aid flow from UN agencies (US$) of 2007 in Least developed countries to that in Lower middle income?
Provide a succinct answer. 158.17. What is the ratio of the Aid flow from UN agencies (US$) in 2008 in Least developed countries to that in Lower middle income?
Ensure brevity in your answer.  9.88. What is the ratio of the Aid flow from UN agencies (US$) of 2009 in Least developed countries to that in Lower middle income?
Offer a very short reply. 8.44. What is the ratio of the Aid flow from UN agencies (US$) of 2010 in Least developed countries to that in Lower middle income?
Ensure brevity in your answer.  9.36. What is the ratio of the Aid flow from UN agencies (US$) of 2008 in Least developed countries to that in Sub-Saharan Africa (all income levels)?
Offer a very short reply. 0.9. What is the ratio of the Aid flow from UN agencies (US$) in 2009 in Least developed countries to that in Sub-Saharan Africa (all income levels)?
Give a very brief answer. 0.93. What is the ratio of the Aid flow from UN agencies (US$) in 2010 in Least developed countries to that in Sub-Saharan Africa (all income levels)?
Ensure brevity in your answer.  1.17. What is the ratio of the Aid flow from UN agencies (US$) in 2007 in Least developed countries to that in Sub-Saharan Africa (developing only)?
Ensure brevity in your answer.  0.99. What is the ratio of the Aid flow from UN agencies (US$) of 2008 in Least developed countries to that in Sub-Saharan Africa (developing only)?
Offer a very short reply. 0.9. What is the ratio of the Aid flow from UN agencies (US$) in 2009 in Least developed countries to that in Sub-Saharan Africa (developing only)?
Keep it short and to the point. 0.93. What is the ratio of the Aid flow from UN agencies (US$) in 2010 in Least developed countries to that in Sub-Saharan Africa (developing only)?
Ensure brevity in your answer.  1.17. What is the ratio of the Aid flow from UN agencies (US$) in 2007 in Low income to that in Lower middle income?
Your answer should be compact. 158.17. What is the ratio of the Aid flow from UN agencies (US$) in 2008 in Low income to that in Lower middle income?
Give a very brief answer. 9.98. What is the ratio of the Aid flow from UN agencies (US$) in 2009 in Low income to that in Lower middle income?
Your answer should be very brief. 8.48. What is the ratio of the Aid flow from UN agencies (US$) in 2010 in Low income to that in Lower middle income?
Your response must be concise. 8.91. What is the ratio of the Aid flow from UN agencies (US$) of 2007 in Low income to that in Sub-Saharan Africa (all income levels)?
Your answer should be compact. 0.99. What is the ratio of the Aid flow from UN agencies (US$) of 2008 in Low income to that in Sub-Saharan Africa (all income levels)?
Give a very brief answer. 0.91. What is the ratio of the Aid flow from UN agencies (US$) in 2009 in Low income to that in Sub-Saharan Africa (all income levels)?
Your response must be concise. 0.94. What is the ratio of the Aid flow from UN agencies (US$) of 2010 in Low income to that in Sub-Saharan Africa (all income levels)?
Your answer should be compact. 1.11. What is the ratio of the Aid flow from UN agencies (US$) of 2007 in Low income to that in Sub-Saharan Africa (developing only)?
Give a very brief answer. 0.99. What is the ratio of the Aid flow from UN agencies (US$) of 2008 in Low income to that in Sub-Saharan Africa (developing only)?
Make the answer very short. 0.91. What is the ratio of the Aid flow from UN agencies (US$) of 2009 in Low income to that in Sub-Saharan Africa (developing only)?
Offer a terse response. 0.94. What is the ratio of the Aid flow from UN agencies (US$) of 2010 in Low income to that in Sub-Saharan Africa (developing only)?
Give a very brief answer. 1.11. What is the ratio of the Aid flow from UN agencies (US$) of 2007 in Lower middle income to that in Sub-Saharan Africa (all income levels)?
Your response must be concise. 0.01. What is the ratio of the Aid flow from UN agencies (US$) in 2008 in Lower middle income to that in Sub-Saharan Africa (all income levels)?
Provide a succinct answer. 0.09. What is the ratio of the Aid flow from UN agencies (US$) in 2009 in Lower middle income to that in Sub-Saharan Africa (all income levels)?
Provide a succinct answer. 0.11. What is the ratio of the Aid flow from UN agencies (US$) of 2010 in Lower middle income to that in Sub-Saharan Africa (all income levels)?
Your answer should be very brief. 0.12. What is the ratio of the Aid flow from UN agencies (US$) of 2007 in Lower middle income to that in Sub-Saharan Africa (developing only)?
Your answer should be very brief. 0.01. What is the ratio of the Aid flow from UN agencies (US$) in 2008 in Lower middle income to that in Sub-Saharan Africa (developing only)?
Make the answer very short. 0.09. What is the ratio of the Aid flow from UN agencies (US$) in 2009 in Lower middle income to that in Sub-Saharan Africa (developing only)?
Offer a very short reply. 0.11. What is the ratio of the Aid flow from UN agencies (US$) of 2010 in Lower middle income to that in Sub-Saharan Africa (developing only)?
Your response must be concise. 0.12. What is the ratio of the Aid flow from UN agencies (US$) of 2007 in Sub-Saharan Africa (all income levels) to that in Sub-Saharan Africa (developing only)?
Make the answer very short. 1. What is the ratio of the Aid flow from UN agencies (US$) of 2009 in Sub-Saharan Africa (all income levels) to that in Sub-Saharan Africa (developing only)?
Make the answer very short. 1. What is the difference between the highest and the second highest Aid flow from UN agencies (US$) in 2007?
Ensure brevity in your answer.  0. What is the difference between the highest and the second highest Aid flow from UN agencies (US$) in 2008?
Your answer should be very brief. 0. What is the difference between the highest and the second highest Aid flow from UN agencies (US$) in 2010?
Make the answer very short. 2.32e+06. What is the difference between the highest and the lowest Aid flow from UN agencies (US$) of 2007?
Provide a short and direct response. 9.49e+06. What is the difference between the highest and the lowest Aid flow from UN agencies (US$) in 2008?
Provide a short and direct response. 3.05e+07. What is the difference between the highest and the lowest Aid flow from UN agencies (US$) in 2009?
Make the answer very short. 3.66e+07. What is the difference between the highest and the lowest Aid flow from UN agencies (US$) of 2010?
Make the answer very short. 4.30e+07. 